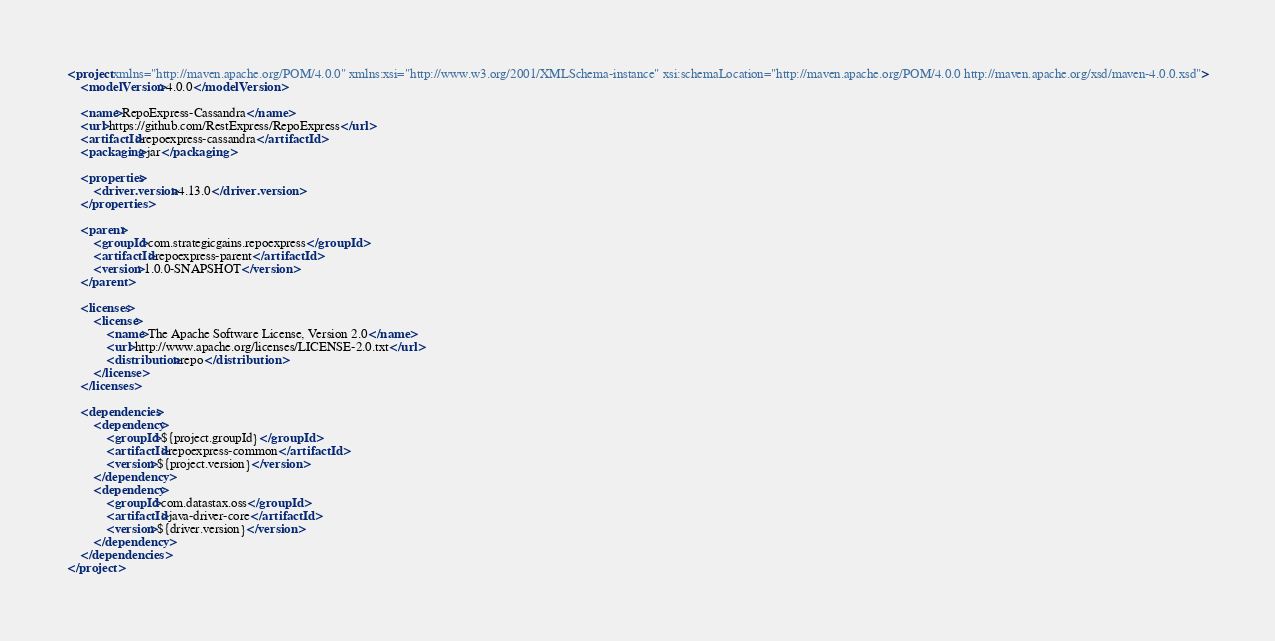Convert code to text. <code><loc_0><loc_0><loc_500><loc_500><_XML_><project xmlns="http://maven.apache.org/POM/4.0.0" xmlns:xsi="http://www.w3.org/2001/XMLSchema-instance" xsi:schemaLocation="http://maven.apache.org/POM/4.0.0 http://maven.apache.org/xsd/maven-4.0.0.xsd">
	<modelVersion>4.0.0</modelVersion>

	<name>RepoExpress-Cassandra</name>
	<url>https://github.com/RestExpress/RepoExpress</url>
	<artifactId>repoexpress-cassandra</artifactId>
	<packaging>jar</packaging>

	<properties>
		<driver.version>4.13.0</driver.version>
	</properties>

	<parent>
		<groupId>com.strategicgains.repoexpress</groupId>
		<artifactId>repoexpress-parent</artifactId>
		<version>1.0.0-SNAPSHOT</version>
	</parent>

	<licenses>
		<license>
			<name>The Apache Software License, Version 2.0</name>
			<url>http://www.apache.org/licenses/LICENSE-2.0.txt</url>
			<distribution>repo</distribution>
		</license>
	</licenses>

	<dependencies>
		<dependency>
			<groupId>${project.groupId}</groupId>
			<artifactId>repoexpress-common</artifactId>
			<version>${project.version}</version>
		</dependency>
		<dependency>
			<groupId>com.datastax.oss</groupId>
			<artifactId>java-driver-core</artifactId>
			<version>${driver.version}</version>
		</dependency>
	</dependencies>
</project></code> 